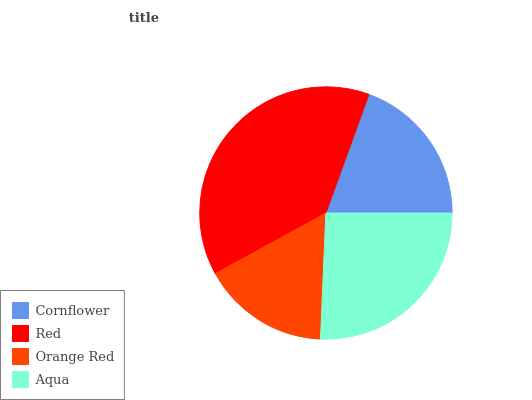Is Orange Red the minimum?
Answer yes or no. Yes. Is Red the maximum?
Answer yes or no. Yes. Is Red the minimum?
Answer yes or no. No. Is Orange Red the maximum?
Answer yes or no. No. Is Red greater than Orange Red?
Answer yes or no. Yes. Is Orange Red less than Red?
Answer yes or no. Yes. Is Orange Red greater than Red?
Answer yes or no. No. Is Red less than Orange Red?
Answer yes or no. No. Is Aqua the high median?
Answer yes or no. Yes. Is Cornflower the low median?
Answer yes or no. Yes. Is Orange Red the high median?
Answer yes or no. No. Is Aqua the low median?
Answer yes or no. No. 